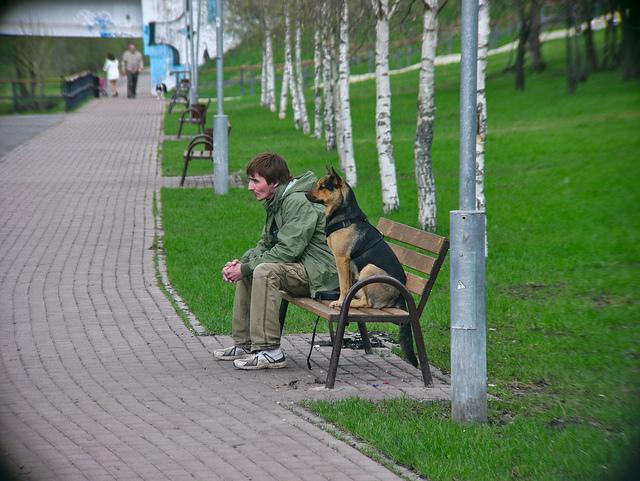What is the black strap hanging from the bench called?

Choices:
A) collar
B) necklace
C) whip
D) leash leash 